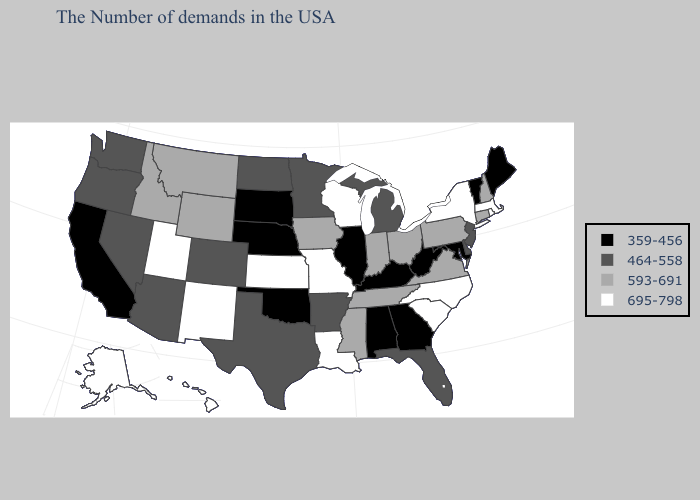Which states hav the highest value in the West?
Keep it brief. New Mexico, Utah, Alaska, Hawaii. Among the states that border Iowa , which have the highest value?
Quick response, please. Wisconsin, Missouri. Does Wisconsin have the highest value in the USA?
Quick response, please. Yes. Does Texas have the lowest value in the USA?
Concise answer only. No. What is the value of Iowa?
Write a very short answer. 593-691. Does the map have missing data?
Concise answer only. No. What is the lowest value in states that border California?
Answer briefly. 464-558. How many symbols are there in the legend?
Write a very short answer. 4. Among the states that border Michigan , does Ohio have the lowest value?
Keep it brief. Yes. Does South Carolina have the highest value in the South?
Give a very brief answer. Yes. What is the highest value in states that border Montana?
Concise answer only. 593-691. How many symbols are there in the legend?
Keep it brief. 4. Does Idaho have the highest value in the USA?
Concise answer only. No. Does Nebraska have a lower value than Ohio?
Answer briefly. Yes. Which states have the lowest value in the USA?
Be succinct. Maine, Vermont, Maryland, West Virginia, Georgia, Kentucky, Alabama, Illinois, Nebraska, Oklahoma, South Dakota, California. 